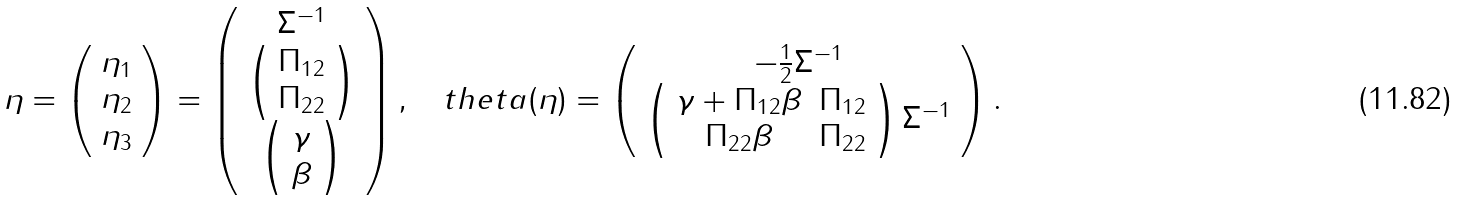Convert formula to latex. <formula><loc_0><loc_0><loc_500><loc_500>\eta = \left ( \begin{array} { c } \eta _ { 1 } \\ \eta _ { 2 } \\ \eta _ { 3 } \end{array} \right ) = \left ( \begin{array} { c } \Sigma ^ { - 1 } \\ \left ( \begin{array} { c } \Pi _ { 1 2 } \\ \Pi _ { 2 2 } \end{array} \right ) \\ \left ( \begin{array} { c } \gamma \\ \beta \end{array} \right ) \\ \end{array} \right ) , \quad t h e t a ( \eta ) = \left ( \begin{array} { c } - \frac { 1 } { 2 } \Sigma ^ { - 1 } \\ \left ( \begin{array} { c c } \gamma + \Pi _ { 1 2 } \beta & \Pi _ { 1 2 } \\ \Pi _ { 2 2 } \beta & \Pi _ { 2 2 } \\ \end{array} \right ) \Sigma ^ { - 1 } \end{array} \right ) .</formula> 